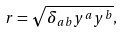<formula> <loc_0><loc_0><loc_500><loc_500>r = \sqrt { \delta _ { a b } y ^ { a } y ^ { b } } ,</formula> 